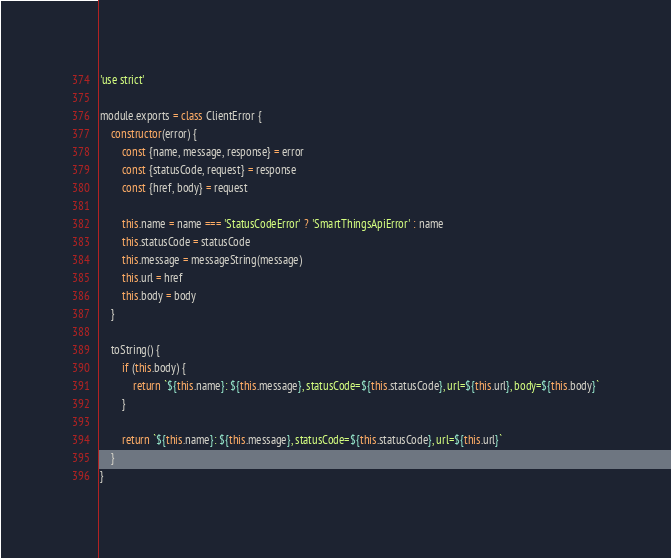<code> <loc_0><loc_0><loc_500><loc_500><_JavaScript_>'use strict'

module.exports = class ClientError {
	constructor(error) {
		const {name, message, response} = error
		const {statusCode, request} = response
		const {href, body} = request

		this.name = name === 'StatusCodeError' ? 'SmartThingsApiError' : name
		this.statusCode = statusCode
		this.message = messageString(message)
		this.url = href
		this.body = body
	}

	toString() {
		if (this.body) {
			return `${this.name}: ${this.message}, statusCode=${this.statusCode}, url=${this.url}, body=${this.body}`
		}

		return `${this.name}: ${this.message}, statusCode=${this.statusCode}, url=${this.url}`
	}
}
</code> 